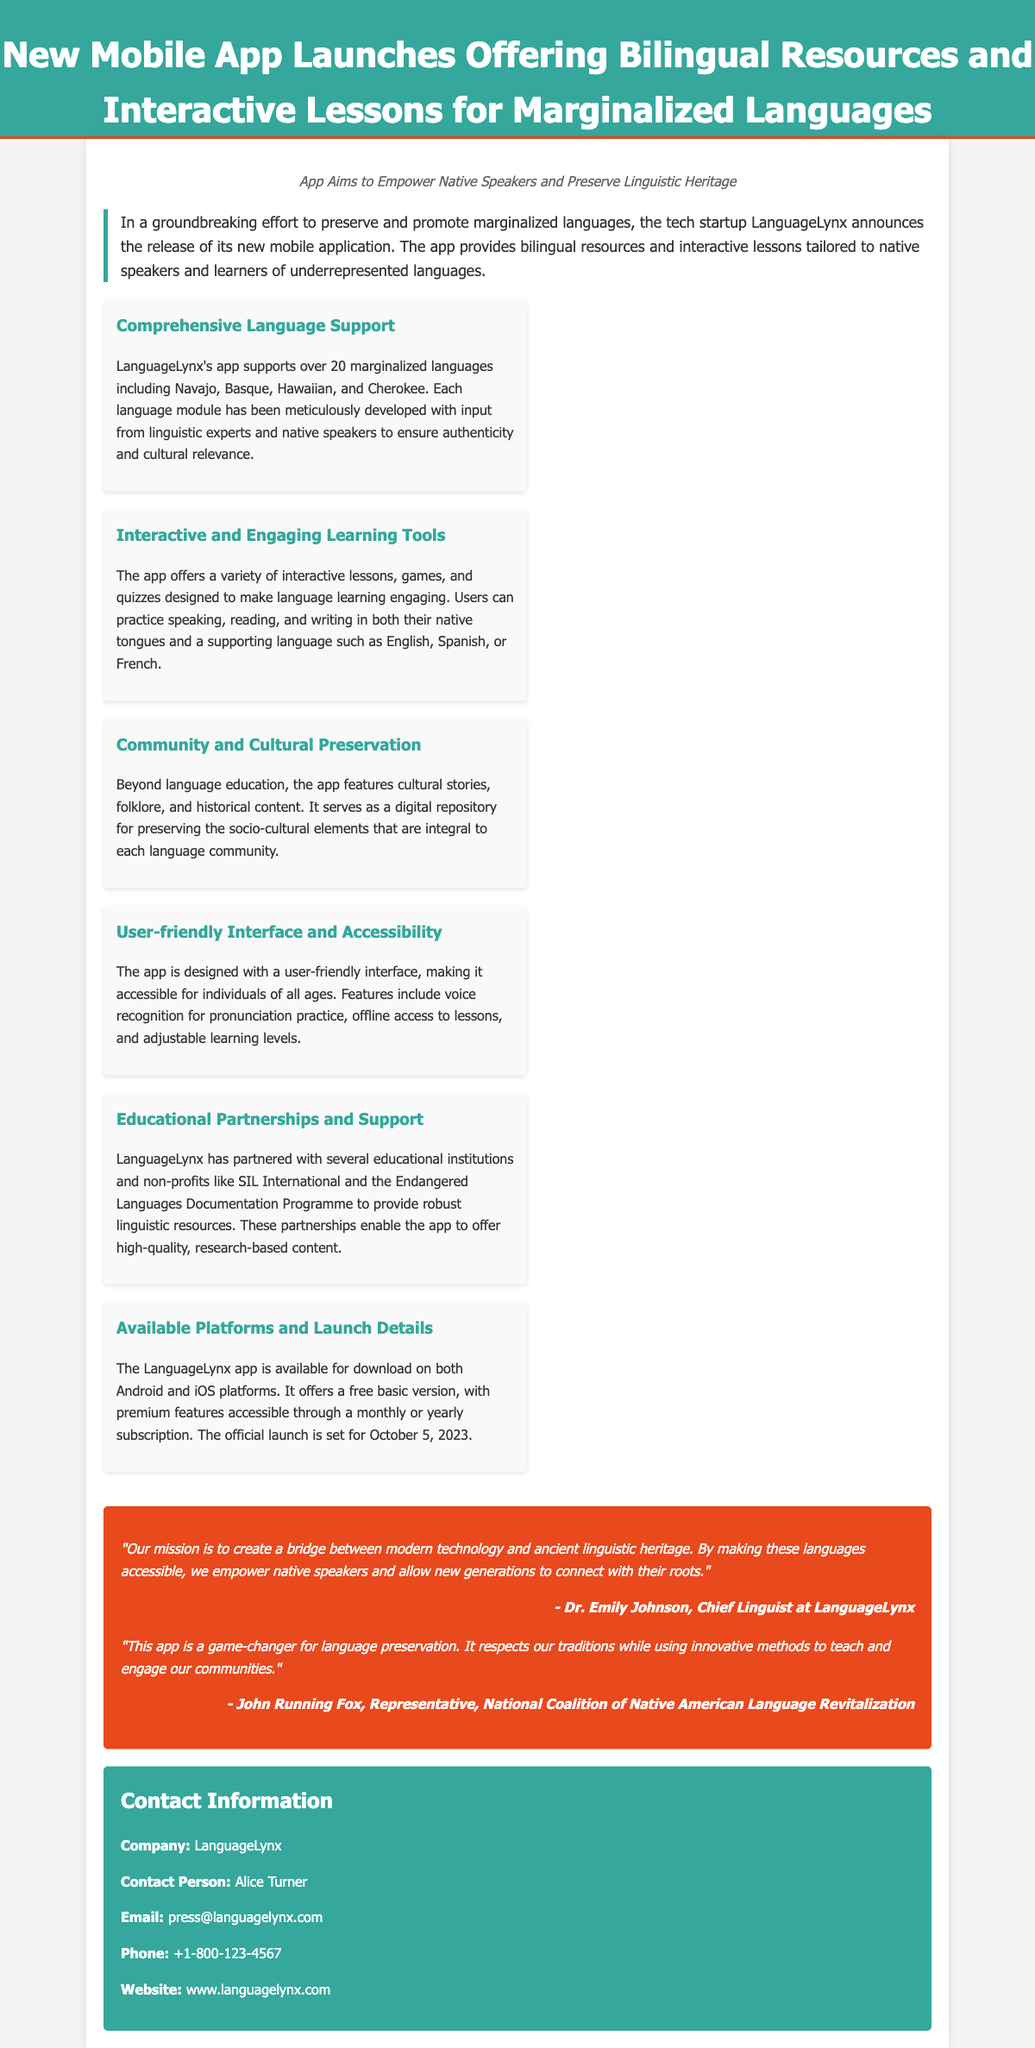What is the name of the app? The app is introduced as "LanguageLynx" in the press release.
Answer: LanguageLynx How many marginalized languages does the app support? The app supports over 20 marginalized languages, as stated in the key point about comprehensive language support.
Answer: over 20 When is the official launch date of the app? The launch date is mentioned in the "Available Platforms and Launch Details" key point.
Answer: October 5, 2023 Who is the Chief Linguist at LanguageLynx? The Chief Linguist is identified as Dr. Emily Johnson in one of the quotes.
Answer: Dr. Emily Johnson What type of users is the app designed for? The app is designed for native speakers and learners of underrepresented languages, as emphasized in the introduction.
Answer: native speakers and learners What feature helps with pronunciation practice? The app includes voice recognition for pronunciation practice, which is highlighted under user-friendly interface.
Answer: voice recognition Which organizations has LanguageLynx partnered with? The press release lists SIL International and the Endangered Languages Documentation Programme as partners.
Answer: SIL International and the Endangered Languages Documentation Programme What is the contact person's name for the press release? The contact person is Alice Turner, as provided in the contact information section.
Answer: Alice Turner 